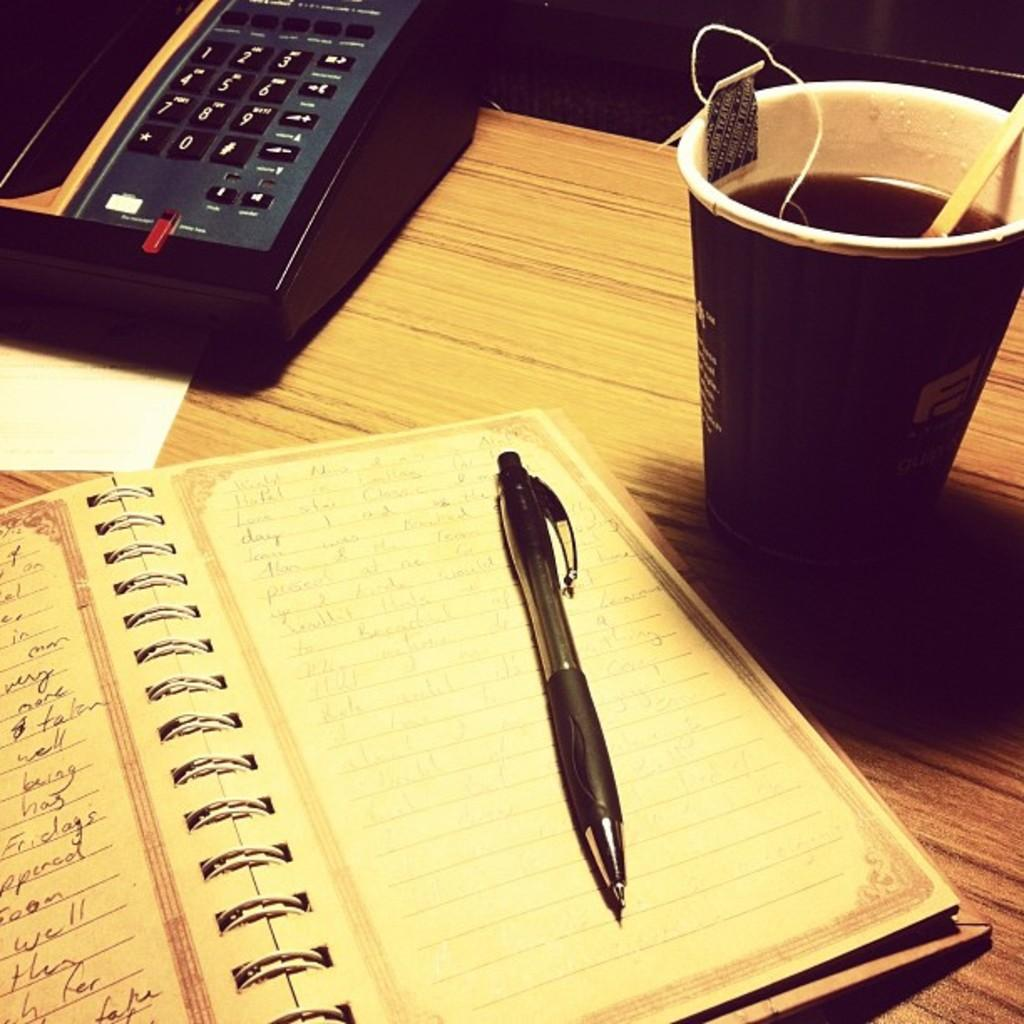What object related to communication is on the table in the image? There is a telephone on the table. What can be found on the table that might be used for drinking? There is a cup with a drink on the table. What object on the table might be used for writing or reading? There is a book on the table. What stationery items are on the table? There is a pen on the table. What might be used for writing on or drawing on in the image? There is paper on the table. What type of curve can be seen in the image? There is no curve present in the image. What authority figure is depicted in the image? There is no authority figure depicted in the image. 